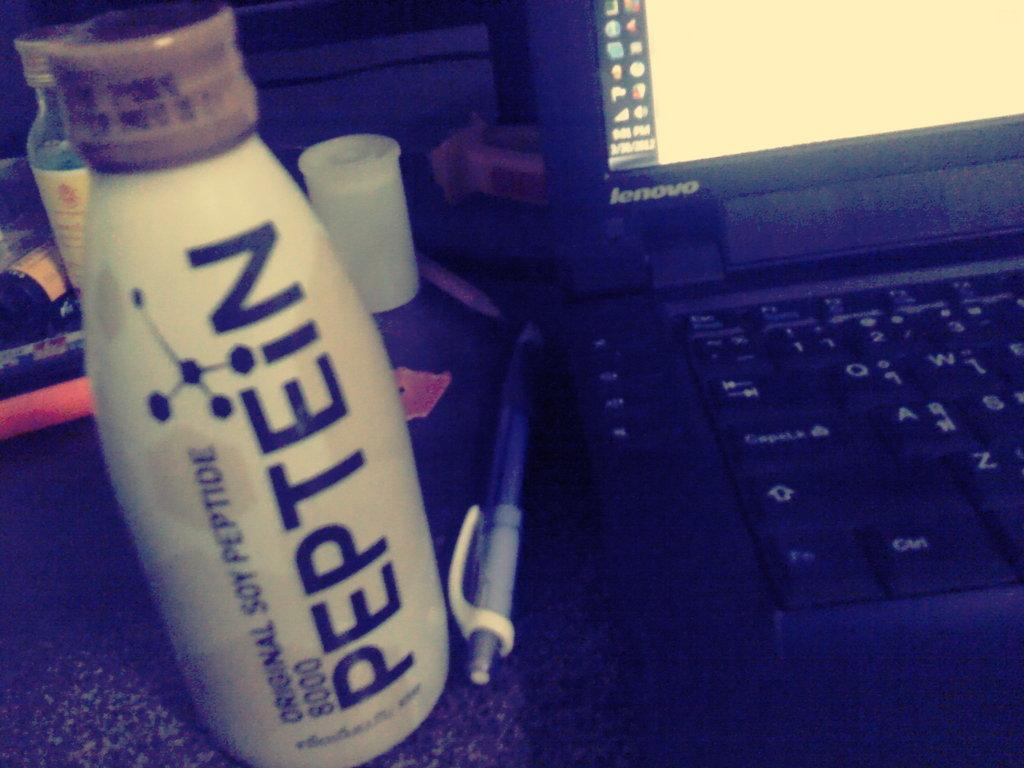<image>
Summarize the visual content of the image. a bottle of Peptein next to a Lenovo lap top computer 